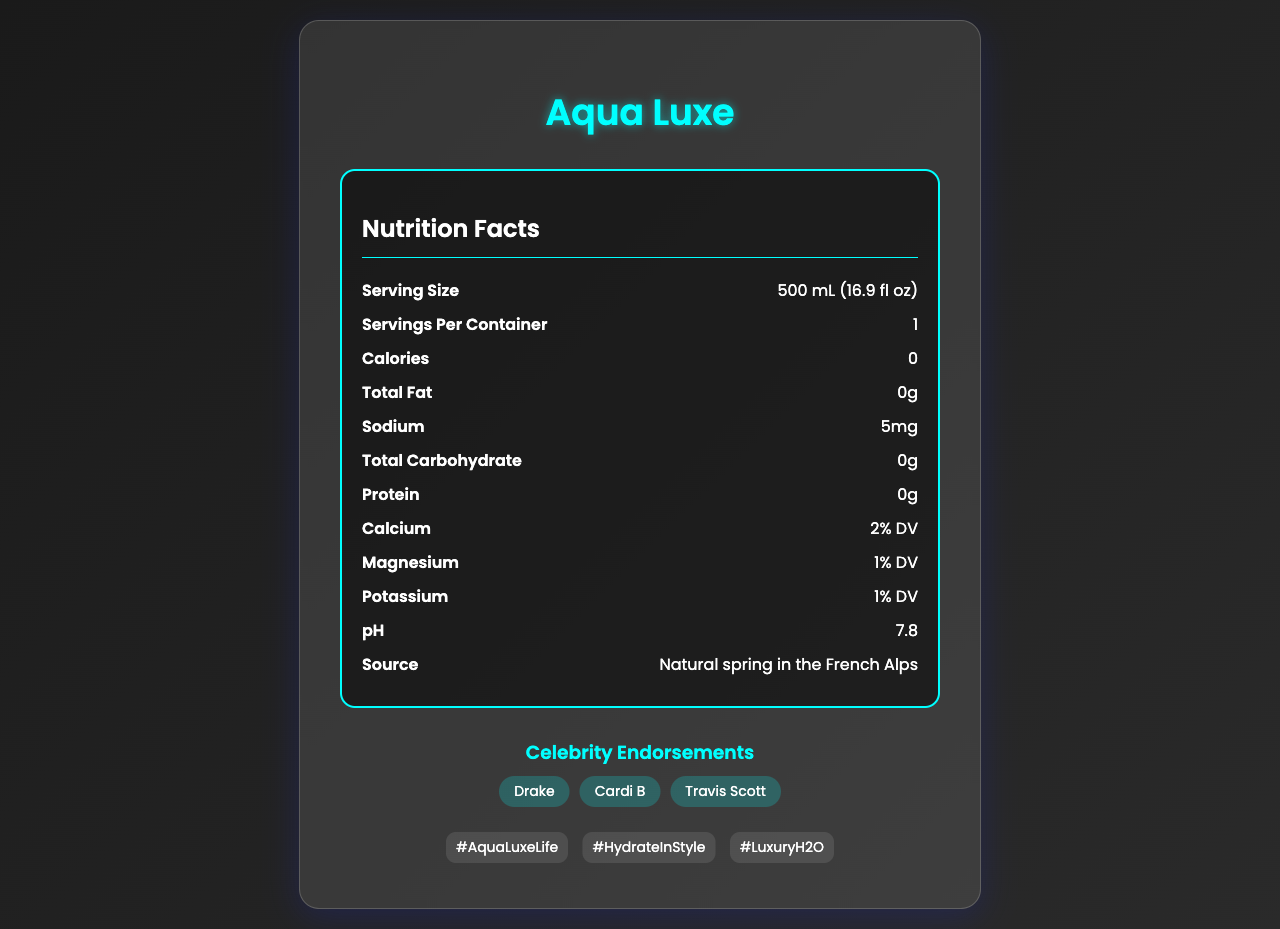what is the serving size of Aqua Luxe bottled water? The serving size information is listed under the "Serving Size" section of the document.
Answer: 500 mL (16.9 fl oz) how many calories are in Aqua Luxe bottled water? The document states that the water contains 0 calories, as indicated in the "Calories" section.
Answer: 0 who are some of the celebrity endorsers of Aqua Luxe? The celebrity endorsements are highlighted in the "Celebrity Endorsements" section.
Answer: Drake, Cardi B, Travis Scott what is the sodium content per serving in Aqua Luxe? The sodium content is specified in the "Sodium" section of the document.
Answer: 5mg where is Aqua Luxe sourced from? The source of Aqua Luxe is mentioned under the "Source" section in the nutrition facts.
Answer: Natural spring in the French Alps which music video appearances are listed for Aqua Luxe? A. In My Feelings - Drake B. Bodak Yellow - Cardi B C. Sicko Mode - Travis Scott D. TKN - Rosalía The music video appearances listed are "Sicko Mode - Travis Scott," "God's Plan - Drake," and "Money - Cardi B."
Answer: C what is the pH level of Aqua Luxe water? The document states that the pH level of Aqua Luxe water is 7.8.
Answer: 7.8 which of the following is an eco-friendly initiative by Aqua Luxe? I. Renewable energy production II. Carbon-neutral production III. 1% of profits donated to clean water charities IV. Reduced plastic use The document mentions that Aqua Luxe has "Carbon-neutral production" and "1% of profits donated to clean water charities" as part of its eco-friendly initiatives. Renewable energy production and reduced plastic use are not mentioned.
Answer: II and III does Aqua Luxe contain any fat? The document states "Total Fat: 0g," meaning there is no fat in Aqua Luxe bottled water.
Answer: No how is Aqua Luxe water filtered? The filtration process is described under the "Filtration Process" section.
Answer: Triple-filtered through diamond-infused membranes describe the main idea of the Aqua Luxe document. The document aims to showcase Aqua Luxe as a luxury water brand by emphasizing its unique features, endorsements by celebrities, and environmental initiatives.
Answer: The document provides detailed information about Aqua Luxe bottled water, including its nutrition facts, mineral content, pH level, source, celebrity endorsements, music video appearances, social media hashtags, limited edition flavors, and eco-friendly initiatives. is Aqua Luxe bottled water high in magnesium content? The document lists magnesium content as "1% DV" and "2mg" per liter, indicating a low magnesium content.
Answer: No what is the award Aqua Luxe received in 2023? The document states that Aqua Luxe won "Best Luxury Water Brand 2023 - Beverage Digest."
Answer: Best Luxury Water Brand - Beverage Digest how many minerals are listed in Aqua Luxe water? The "Minerals per liter" section lists six minerals: calcium, magnesium, potassium, bicarbonate, silica, and chloride.
Answer: Six what are the limited edition flavors of Aqua Luxe? The limited edition flavors are mentioned in the document under the "Limited Edition Flavors" section.
Answer: 24K Gold Infusion, Platinum Electrolyte Boost, Diamond Sparkle how much does a bottle of Aqua Luxe cost? The document does not provide any pricing information for Aqua Luxe bottled water.
Answer: Not enough information what percentage of calcium is in a serving of Aqua Luxe? The document states that a serving of Aqua Luxe contains 2% of the Daily Value (DV) of calcium.
Answer: 2% DV how many servings are there in a container of Aqua Luxe? The document specifies that there is only one serving per container of Aqua Luxe.
Answer: 1 